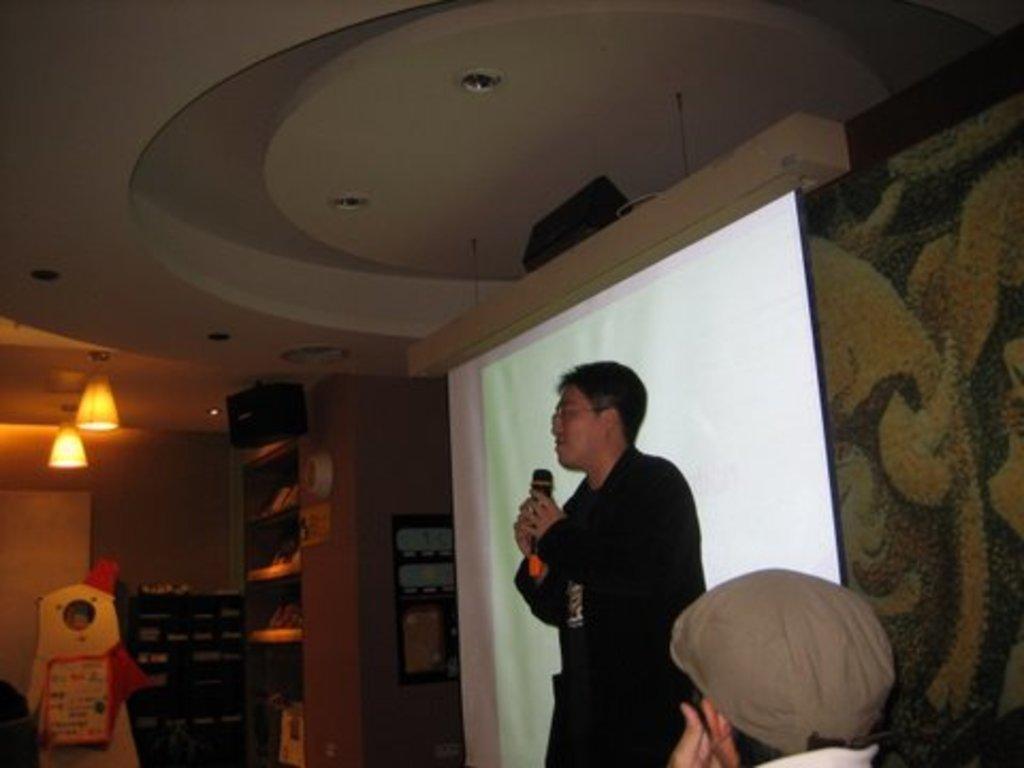Describe this image in one or two sentences. At the top we can see ceiling and lights. In this picture we can see a man standing, holding a mike near to a projector screen. At the bottom portion of the picture we can see a person wearing a cap. In the background we can see racks and objects. We can see a frame on the wall. 